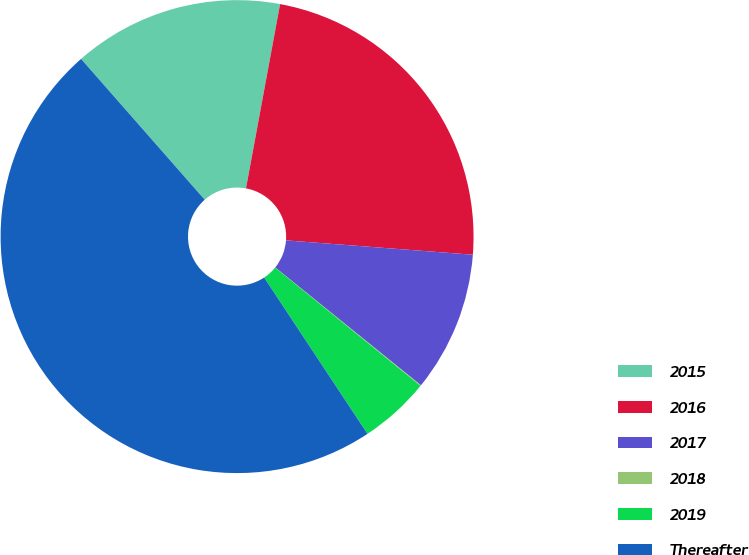Convert chart. <chart><loc_0><loc_0><loc_500><loc_500><pie_chart><fcel>2015<fcel>2016<fcel>2017<fcel>2018<fcel>2019<fcel>Thereafter<nl><fcel>14.38%<fcel>23.31%<fcel>9.6%<fcel>0.05%<fcel>4.83%<fcel>47.83%<nl></chart> 